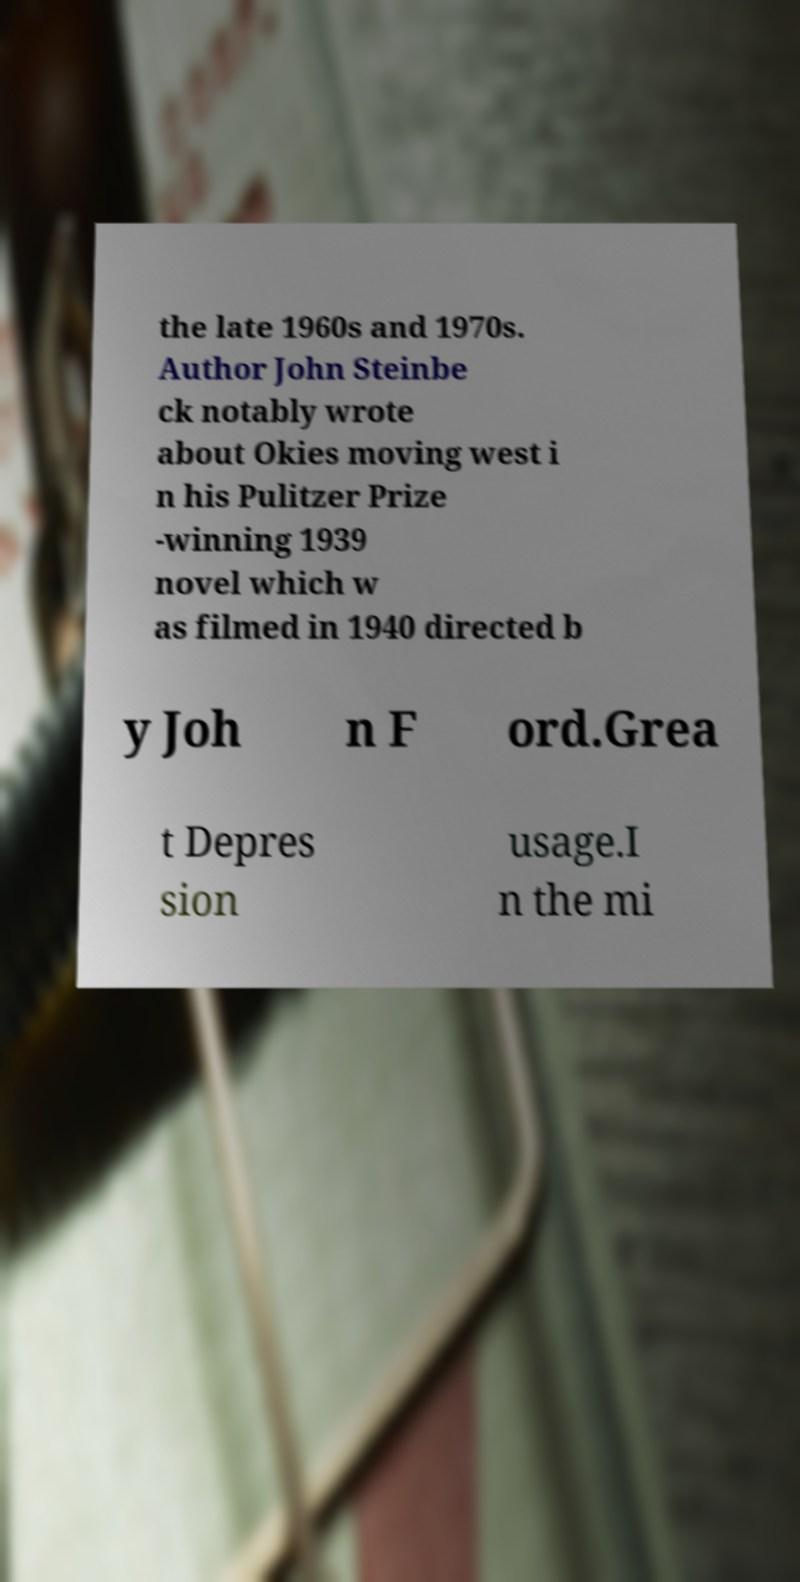Could you assist in decoding the text presented in this image and type it out clearly? the late 1960s and 1970s. Author John Steinbe ck notably wrote about Okies moving west i n his Pulitzer Prize -winning 1939 novel which w as filmed in 1940 directed b y Joh n F ord.Grea t Depres sion usage.I n the mi 